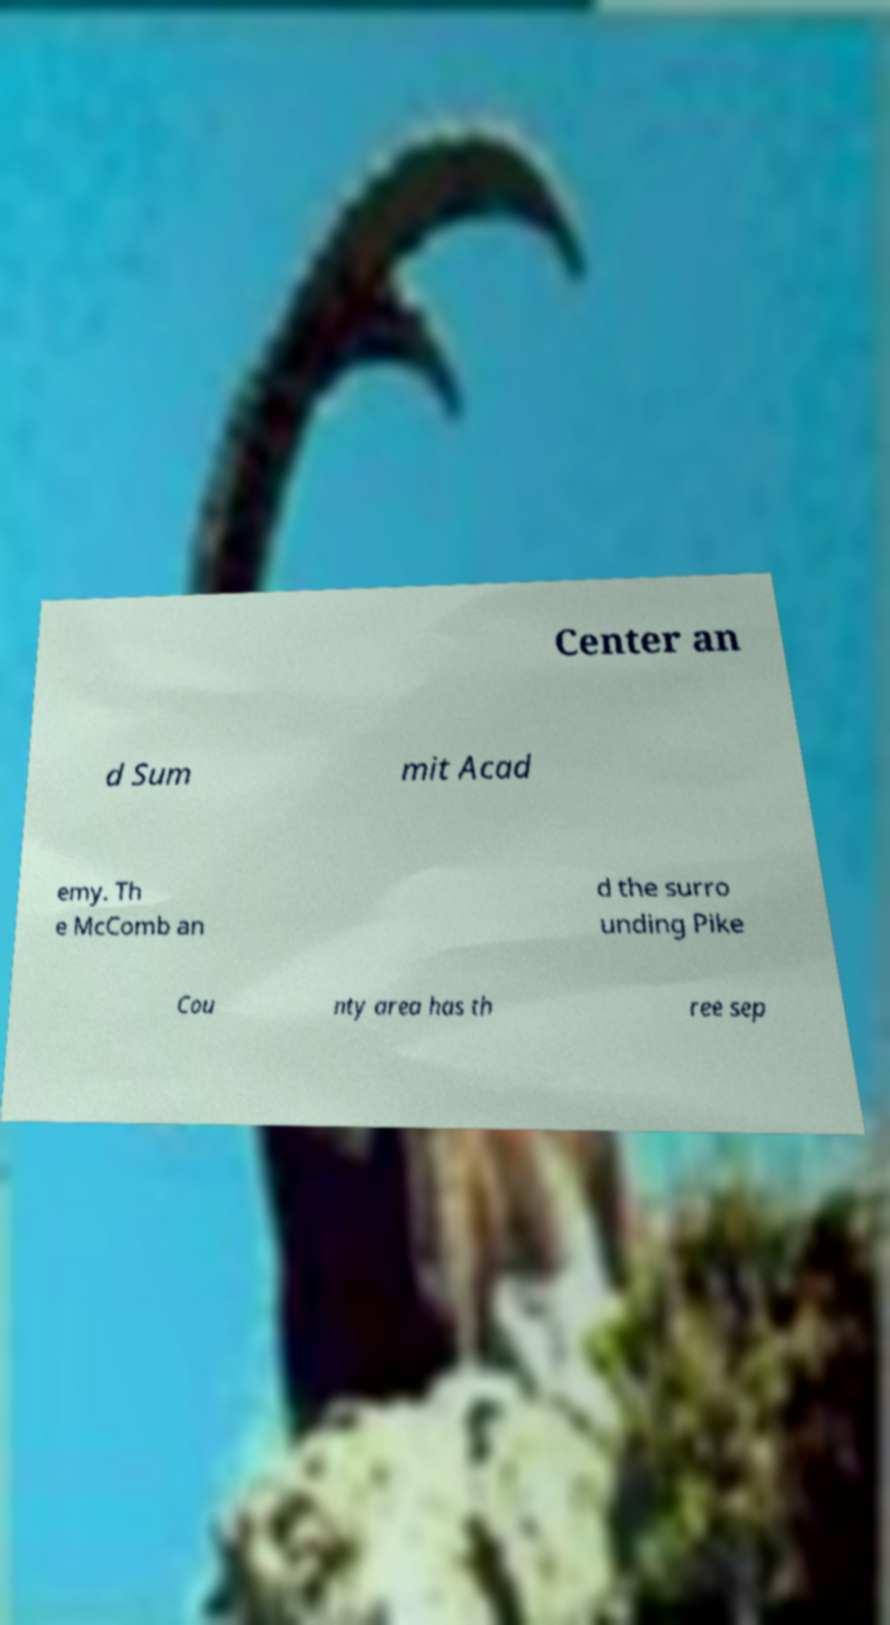There's text embedded in this image that I need extracted. Can you transcribe it verbatim? Center an d Sum mit Acad emy. Th e McComb an d the surro unding Pike Cou nty area has th ree sep 